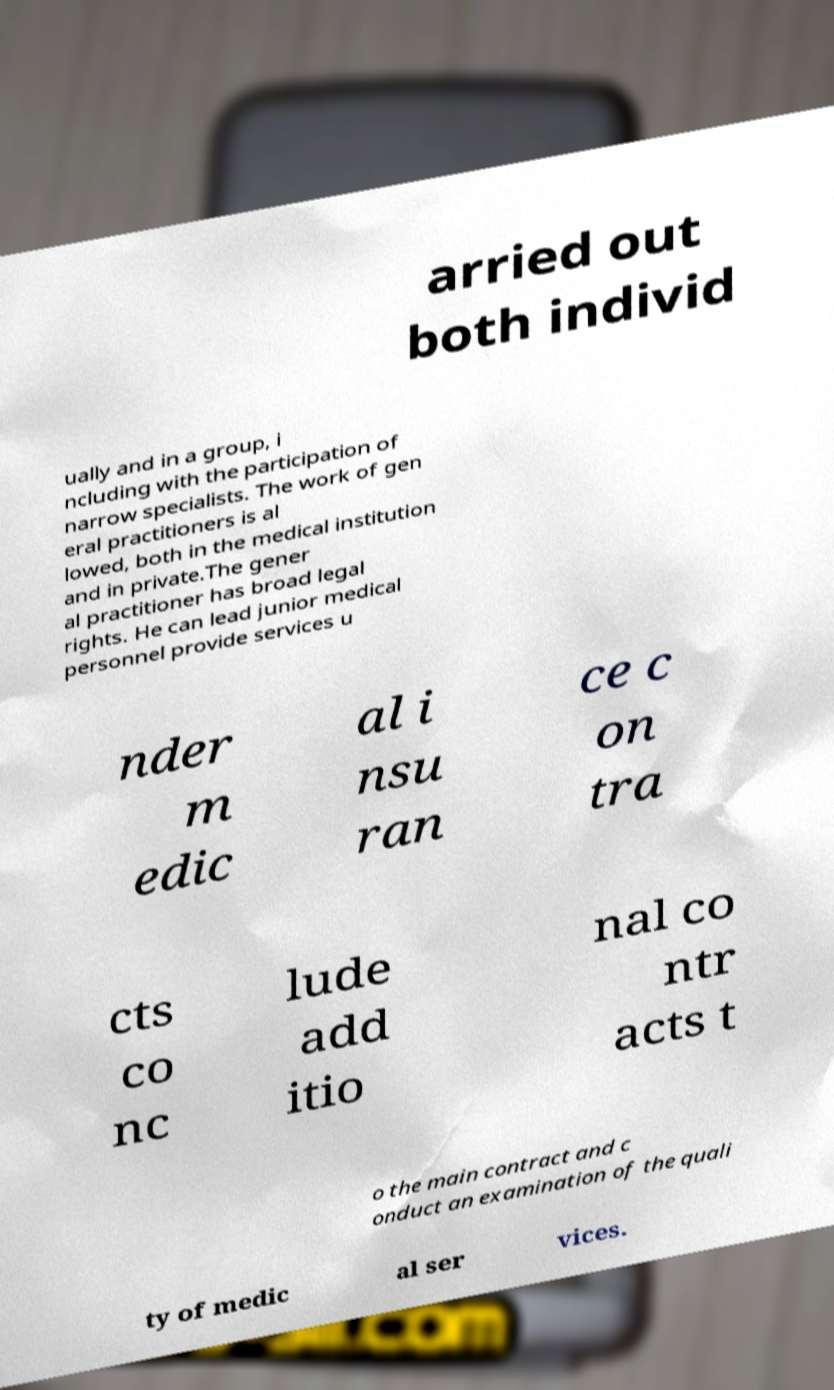I need the written content from this picture converted into text. Can you do that? arried out both individ ually and in a group, i ncluding with the participation of narrow specialists. The work of gen eral practitioners is al lowed, both in the medical institution and in private.The gener al practitioner has broad legal rights. He can lead junior medical personnel provide services u nder m edic al i nsu ran ce c on tra cts co nc lude add itio nal co ntr acts t o the main contract and c onduct an examination of the quali ty of medic al ser vices. 